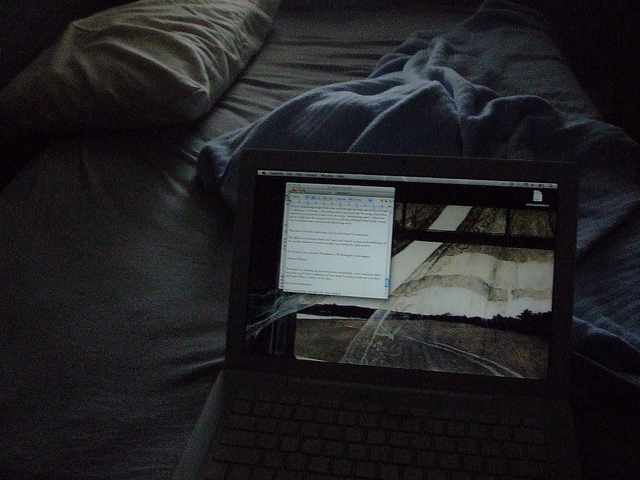<image>Who is sleeping in the bed? No one is sleeping in the bed from the given information. How old is this picture? It is unknown how old this picture is. It could be anywhere from a few days to 10 years old. Who is sleeping in the bed? I don't know who is sleeping in the bed. It can be the owner, a man, or nobody. How old is this picture? It is unknown how old this picture is. It can be seen as new or not very old. 